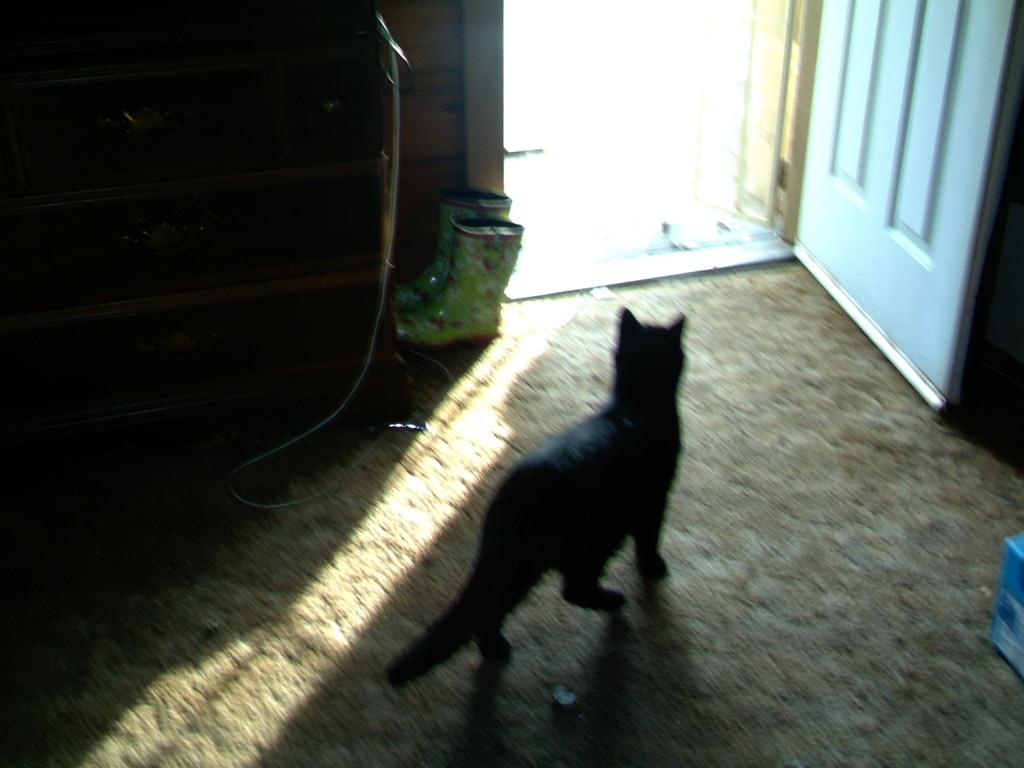What type of animal is in the image? There is a black cat in the image. What other objects can be seen in the image? There are shoes and a white door visible in the image. Can you describe the pipe in the image? There is a pipe in the image, but its specific characteristics are not mentioned in the provided facts. Where is the nest located in the image? There is no nest present in the image. Can you describe the woman in the image? There is no woman present in the image. 